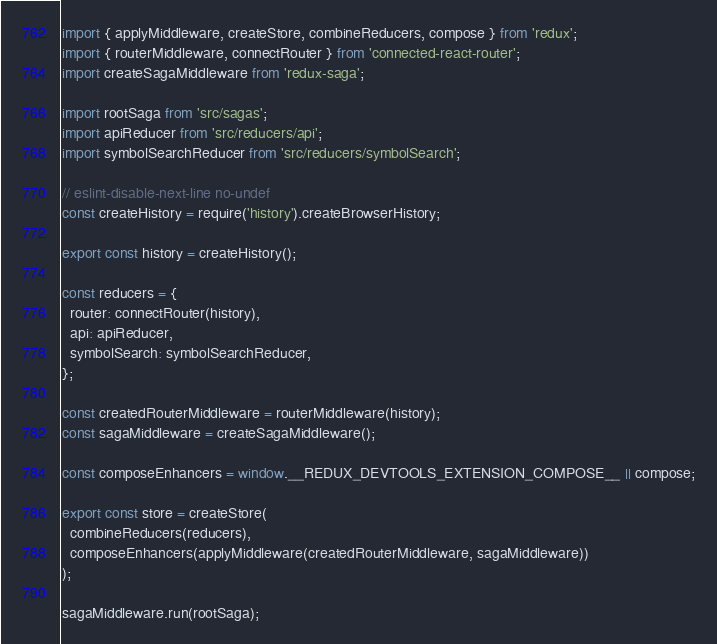<code> <loc_0><loc_0><loc_500><loc_500><_JavaScript_>import { applyMiddleware, createStore, combineReducers, compose } from 'redux';
import { routerMiddleware, connectRouter } from 'connected-react-router';
import createSagaMiddleware from 'redux-saga';

import rootSaga from 'src/sagas';
import apiReducer from 'src/reducers/api';
import symbolSearchReducer from 'src/reducers/symbolSearch';

// eslint-disable-next-line no-undef
const createHistory = require('history').createBrowserHistory;

export const history = createHistory();

const reducers = {
  router: connectRouter(history),
  api: apiReducer,
  symbolSearch: symbolSearchReducer,
};

const createdRouterMiddleware = routerMiddleware(history);
const sagaMiddleware = createSagaMiddleware();

const composeEnhancers = window.__REDUX_DEVTOOLS_EXTENSION_COMPOSE__ || compose;

export const store = createStore(
  combineReducers(reducers),
  composeEnhancers(applyMiddleware(createdRouterMiddleware, sagaMiddleware))
);

sagaMiddleware.run(rootSaga);
</code> 